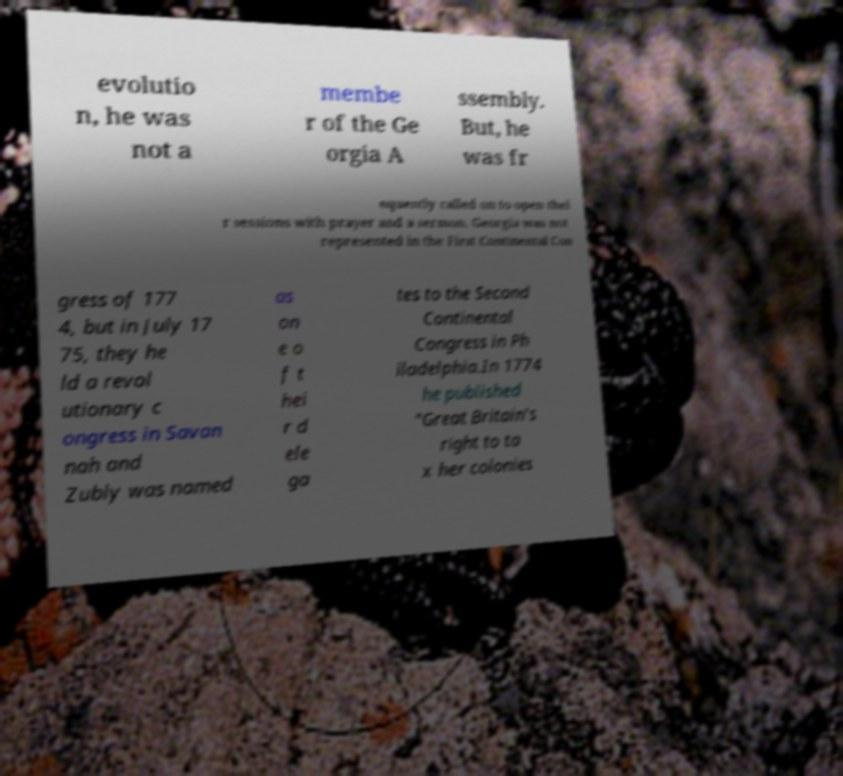Could you assist in decoding the text presented in this image and type it out clearly? evolutio n, he was not a membe r of the Ge orgia A ssembly. But, he was fr equently called on to open thei r sessions with prayer and a sermon. Georgia was not represented in the First Continental Con gress of 177 4, but in July 17 75, they he ld a revol utionary c ongress in Savan nah and Zubly was named as on e o f t hei r d ele ga tes to the Second Continental Congress in Ph iladelphia.In 1774 he published "Great Britain's right to ta x her colonies 